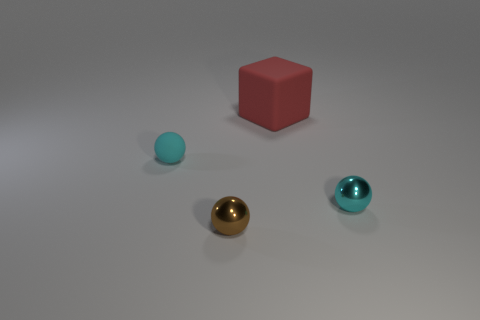Add 4 small cyan metallic balls. How many objects exist? 8 Subtract all cubes. How many objects are left? 3 Add 2 brown metallic things. How many brown metallic things are left? 3 Add 3 small yellow cylinders. How many small yellow cylinders exist? 3 Subtract 0 gray cylinders. How many objects are left? 4 Subtract all tiny cyan shiny objects. Subtract all purple matte cylinders. How many objects are left? 3 